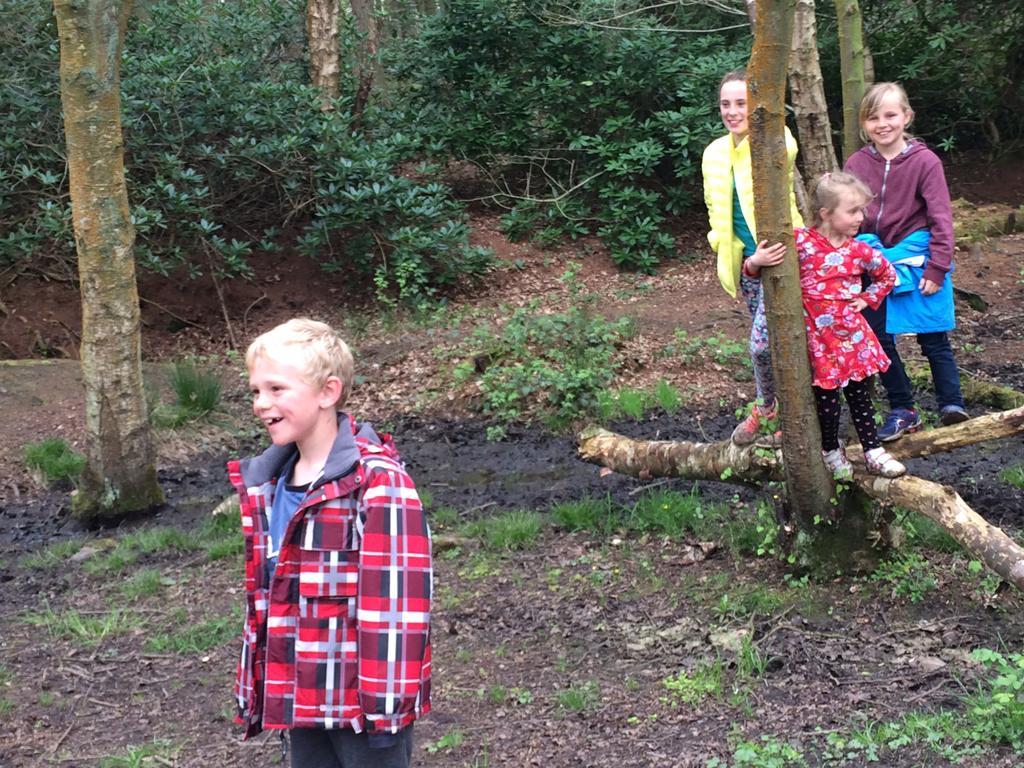Please provide a concise description of this image. In this image there is a boy standing , and at the background there are three persons standing on the branch of the tree , grass, plants. 